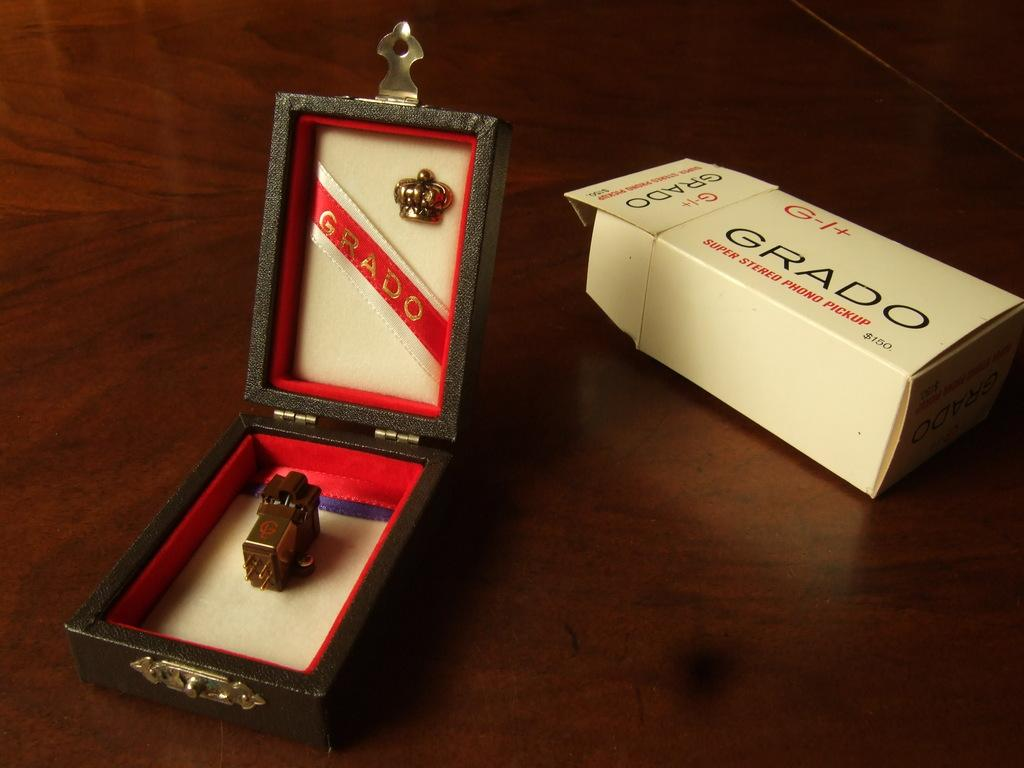How many boxes can be seen in the image? There are two boxes in the image. What is inside the boxes? There is an unspecified object present in the boxes. Is there any text on the boxes? Yes, there is text on the boxes. What type of surface is at the bottom of the image? There is a wooden surface at the bottom of the image. What type of meat is stored in the boxes in the image? There is no meat present in the image; the contents of the boxes are unspecified. What brand of toothpaste is visible on the boxes in the image? There is no toothpaste present in the image; the text on the boxes is unspecified. 